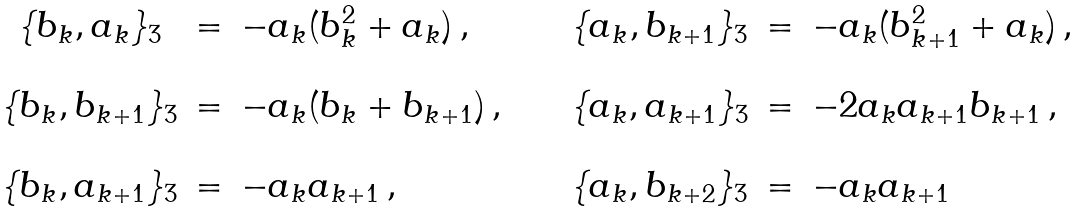Convert formula to latex. <formula><loc_0><loc_0><loc_500><loc_500>\begin{array} { c c l c c c l } \{ b _ { k } , a _ { k } \} _ { 3 } & = & - a _ { k } ( b _ { k } ^ { 2 } + a _ { k } ) \, , & \quad & \{ a _ { k } , b _ { k + 1 } \} _ { 3 } & = & - a _ { k } ( b _ { k + 1 } ^ { 2 } + a _ { k } ) \, , \\ \\ \{ b _ { k } , b _ { k + 1 } \} _ { 3 } & = & - a _ { k } ( b _ { k } + b _ { k + 1 } ) \, , & \quad & \{ a _ { k } , a _ { k + 1 } \} _ { 3 } & = & - 2 a _ { k } a _ { k + 1 } b _ { k + 1 } \, , \\ \\ \{ b _ { k } , a _ { k + 1 } \} _ { 3 } & = & - a _ { k } a _ { k + 1 } \, , & \quad & \{ a _ { k } , b _ { k + 2 } \} _ { 3 } & = & - a _ { k } a _ { k + 1 } \end{array}</formula> 